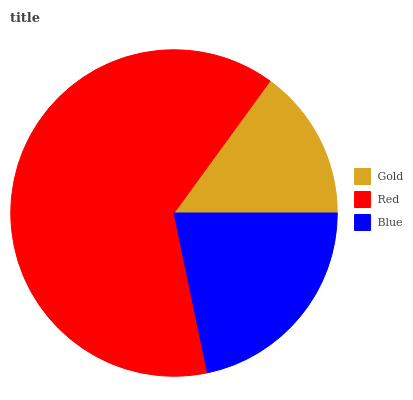Is Gold the minimum?
Answer yes or no. Yes. Is Red the maximum?
Answer yes or no. Yes. Is Blue the minimum?
Answer yes or no. No. Is Blue the maximum?
Answer yes or no. No. Is Red greater than Blue?
Answer yes or no. Yes. Is Blue less than Red?
Answer yes or no. Yes. Is Blue greater than Red?
Answer yes or no. No. Is Red less than Blue?
Answer yes or no. No. Is Blue the high median?
Answer yes or no. Yes. Is Blue the low median?
Answer yes or no. Yes. Is Gold the high median?
Answer yes or no. No. Is Red the low median?
Answer yes or no. No. 